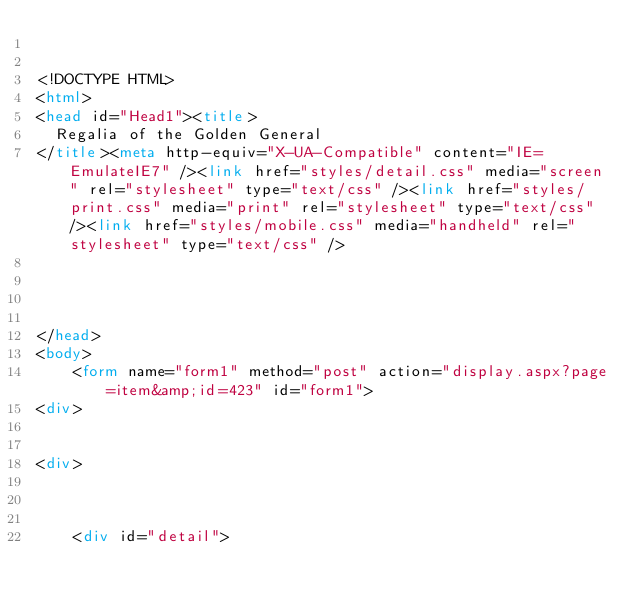Convert code to text. <code><loc_0><loc_0><loc_500><loc_500><_HTML_>

<!DOCTYPE HTML>
<html>
<head id="Head1"><title>
	Regalia of the Golden General
</title><meta http-equiv="X-UA-Compatible" content="IE=EmulateIE7" /><link href="styles/detail.css" media="screen" rel="stylesheet" type="text/css" /><link href="styles/print.css" media="print" rel="stylesheet" type="text/css" /><link href="styles/mobile.css" media="handheld" rel="stylesheet" type="text/css" />
    
    
    

</head>
<body>
    <form name="form1" method="post" action="display.aspx?page=item&amp;id=423" id="form1">
<div>


<div>

	
	
    <div id="detail">
		</code> 